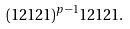<formula> <loc_0><loc_0><loc_500><loc_500>( 1 2 1 2 1 ) ^ { p - 1 } 1 2 1 2 1 .</formula> 